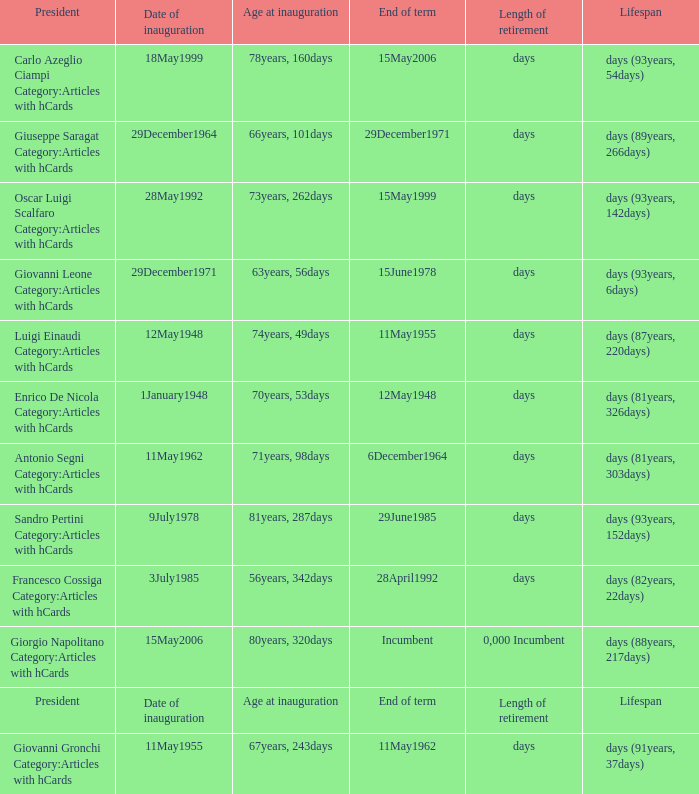What is the Date of inauguration of the President with an Age at inauguration of 73years, 262days? 28May1992. 